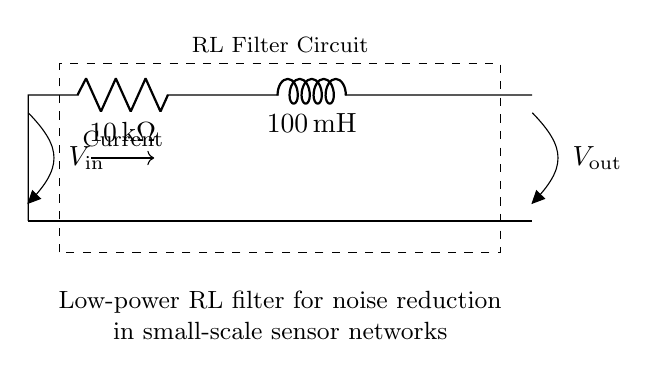What is the resistance value in this circuit? The circuit diagram shows a resistor labeled R1. The value indicated next to R1 is 10 kΩ, which is the resistance.
Answer: 10 kΩ What is the inductance value in this circuit? The circuit diagram includes an inductor labeled L1. The value indicated next to L1 is 100 mH, representing the inductance.
Answer: 100 mH What is the purpose of this RL filter? The circuit is described in the annotation as a low-power RL filter for noise reduction in small-scale sensor networks, indicating its intended function.
Answer: Noise reduction What is the input voltage labeled in the circuit? The diagram labels the input voltage as V_in situated at the left side, directly connected to the resistor. The specific value of the voltage is not given in the diagram.
Answer: V_in What type of filter is represented by this circuit? Understanding the components involved, specifically the series combination of the resistor and inductor, indicates that this is a low-pass filter designed to allow low-frequency signals while attenuating higher frequencies.
Answer: Low-pass filter What is the current direction in the circuit? The circuit has an arrow indicating current flow from the input to the output. Observing the current flow direction noted in the diagram confirms the intended current path in the RL circuit.
Answer: From input to output What is the output voltage labeled in the circuit? Next to the output node located at the right side of the circuit, it is labeled as V_out, showing that it is the voltage across the output terminals. The specific value of this voltage is not provided.
Answer: V_out 